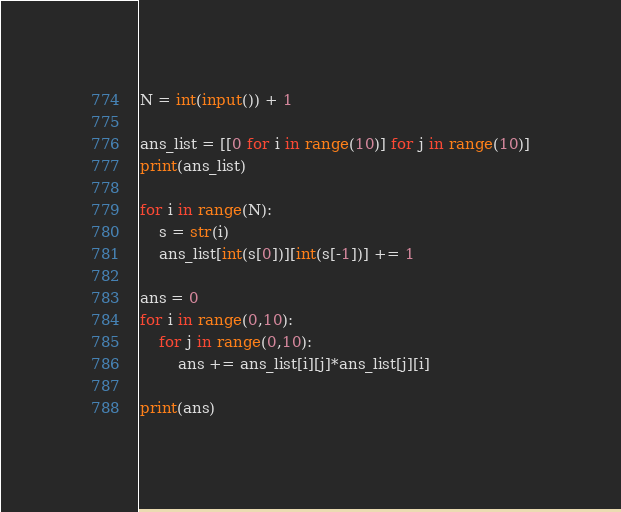Convert code to text. <code><loc_0><loc_0><loc_500><loc_500><_Python_>N = int(input()) + 1

ans_list = [[0 for i in range(10)] for j in range(10)]
print(ans_list)

for i in range(N):
    s = str(i)
    ans_list[int(s[0])][int(s[-1])] += 1

ans = 0
for i in range(0,10):
    for j in range(0,10):
        ans += ans_list[i][j]*ans_list[j][i]

print(ans)</code> 